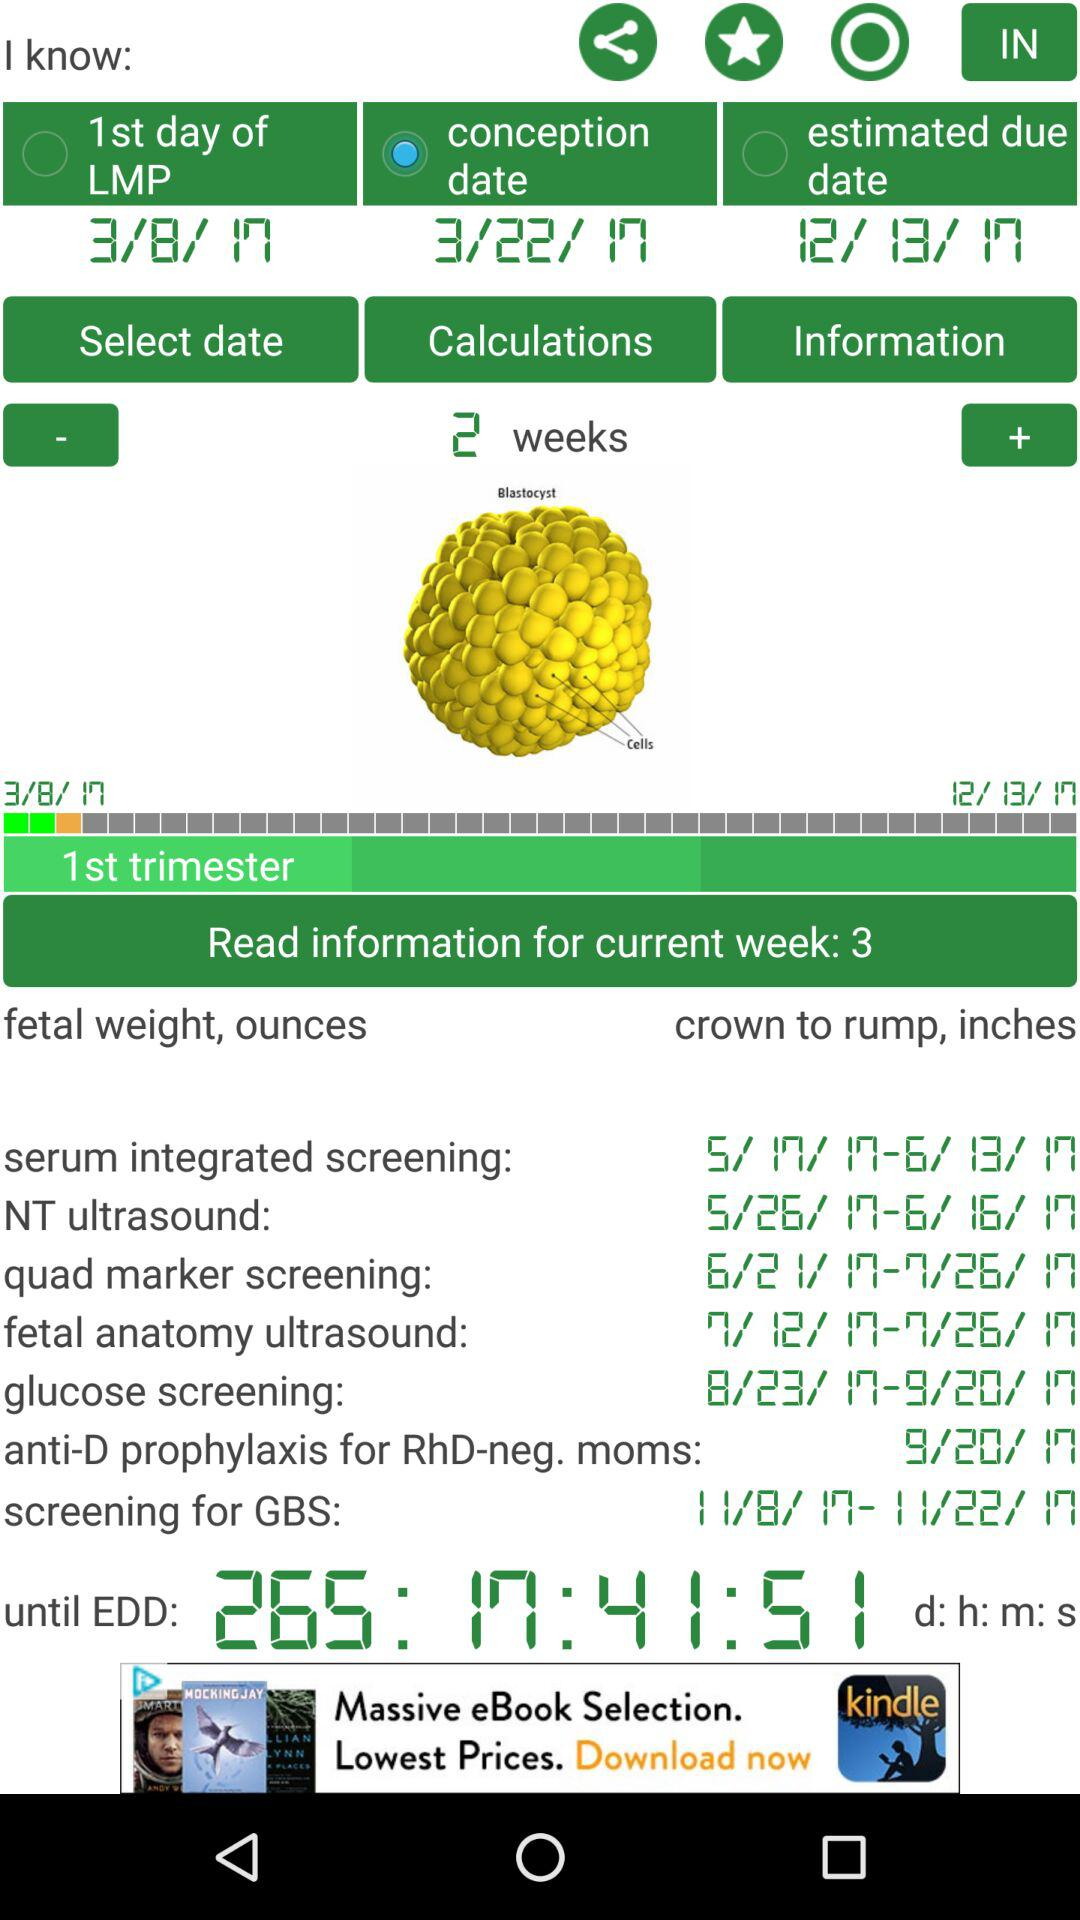How many weeks pregnant is the mother?
Answer the question using a single word or phrase. 3 